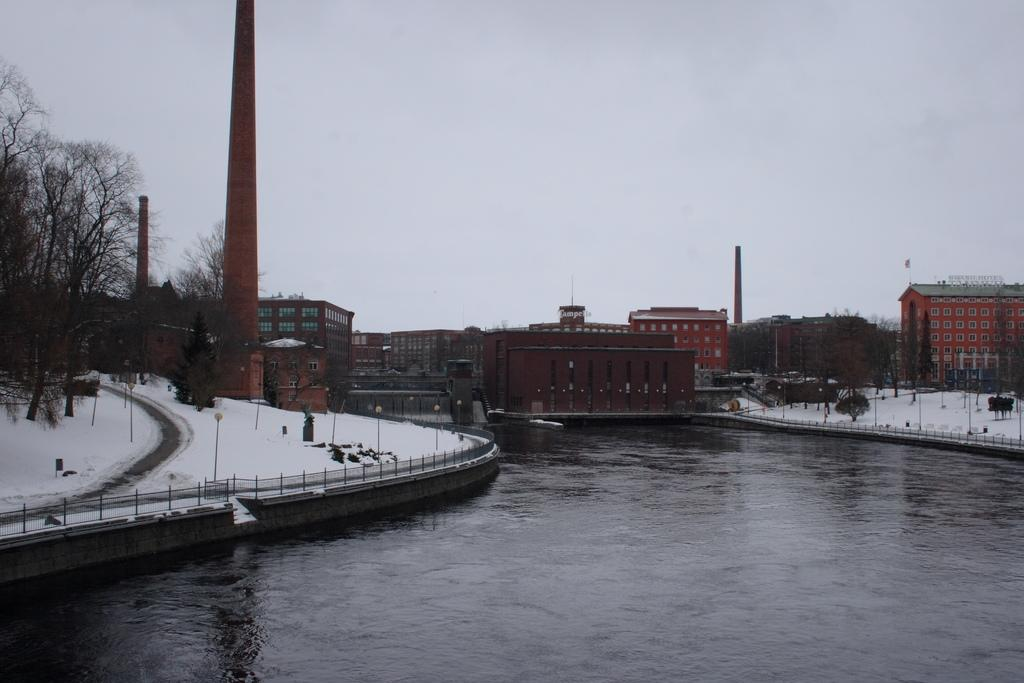What type of water feature is in the image? There is a canal in the image. What is the condition of the ground on either side of the canal? Snow is present on either side of the canal. What can be seen in the distance in the image? There are trees and buildings in the background of the image. What part of the natural environment is visible in the image? The sky is visible in the background of the image. Can you see a gun being used by someone in the image? There is no gun or person using a gun present in the image. How many robins can be seen perched on the trees in the background? There are no robins present in the image; only trees and buildings can be seen in the background. 